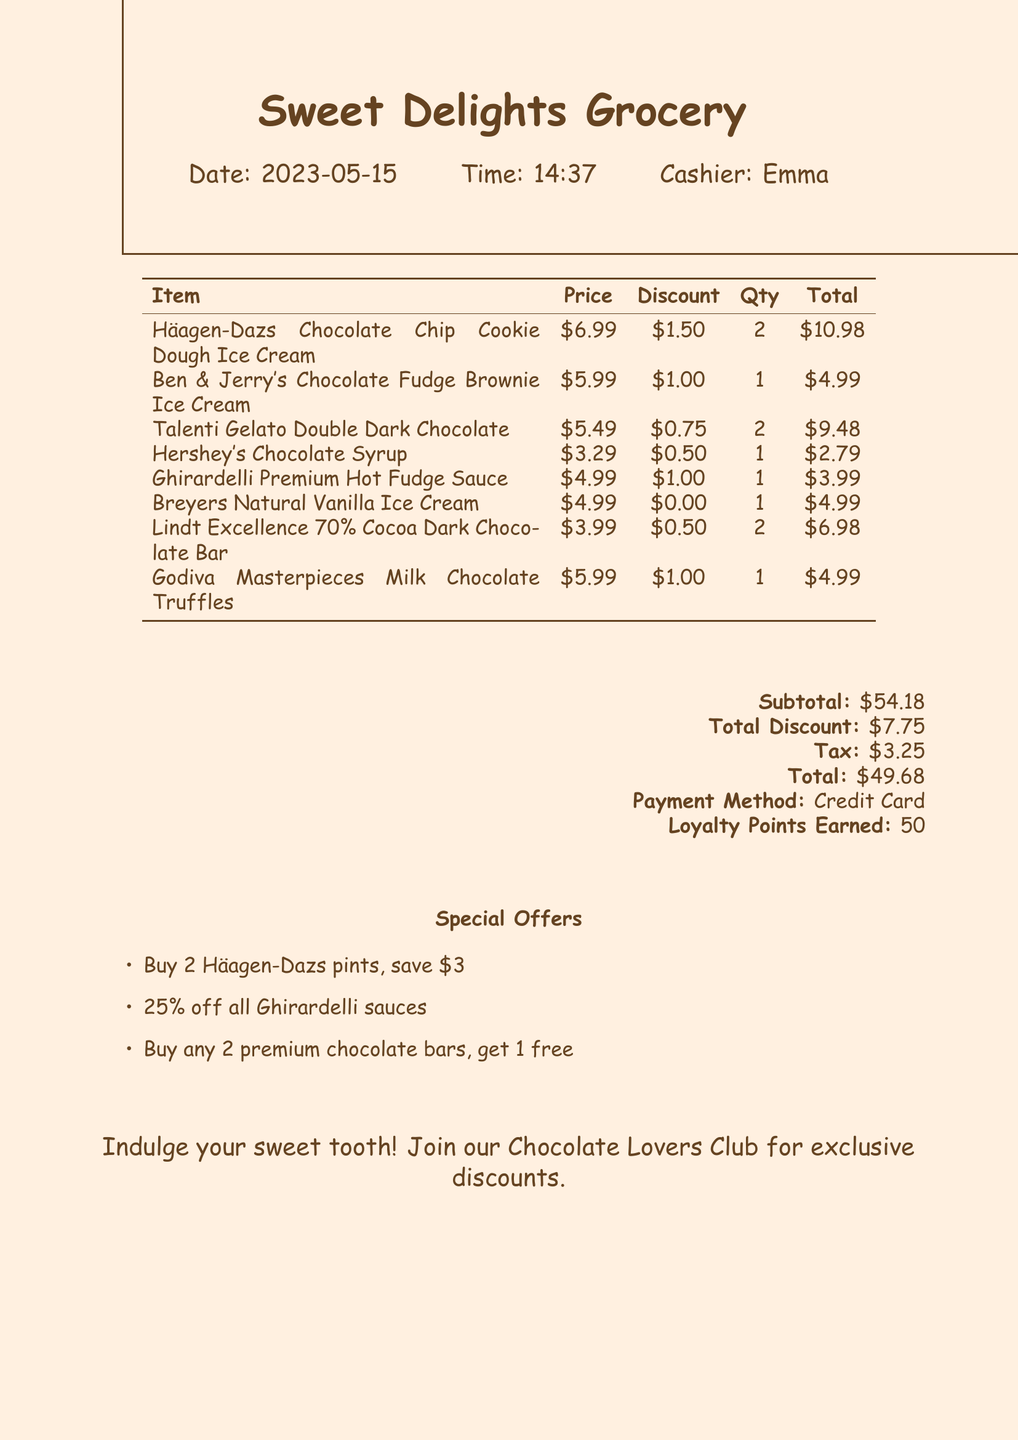What is the store name? The store name is listed at the top of the receipt.
Answer: Sweet Delights Grocery What is the date of the transaction? The date is prominently displayed on the receipt.
Answer: 2023-05-15 How many Häagen-Dazs pints were purchased? The quantity of Häagen-Dazs pints is mentioned next to the item description.
Answer: 2 What was the total discount applied? The total discount is provided in a separate section on the receipt.
Answer: $7.75 How much was the Hershey's Chocolate Syrup? The price of Hershey's Chocolate Syrup is listed in the itemized section.
Answer: $3.29 What is the total amount after tax? The total amount after tax is indicated at the bottom of the receipt.
Answer: $49.68 Which premium ice cream brand received a discount of $1.00? The premium ice cream brands with discounts are shown in the itemized list.
Answer: Ben & Jerry's Chocolate Fudge Brownie Ice Cream What is one of the special offers? The special offers are clearly listed towards the bottom of the receipt.
Answer: Buy 2 Häagen-Dazs pints, save $3 How many loyalty points were earned from this purchase? The number of loyalty points earned is specified near the payment details.
Answer: 50 